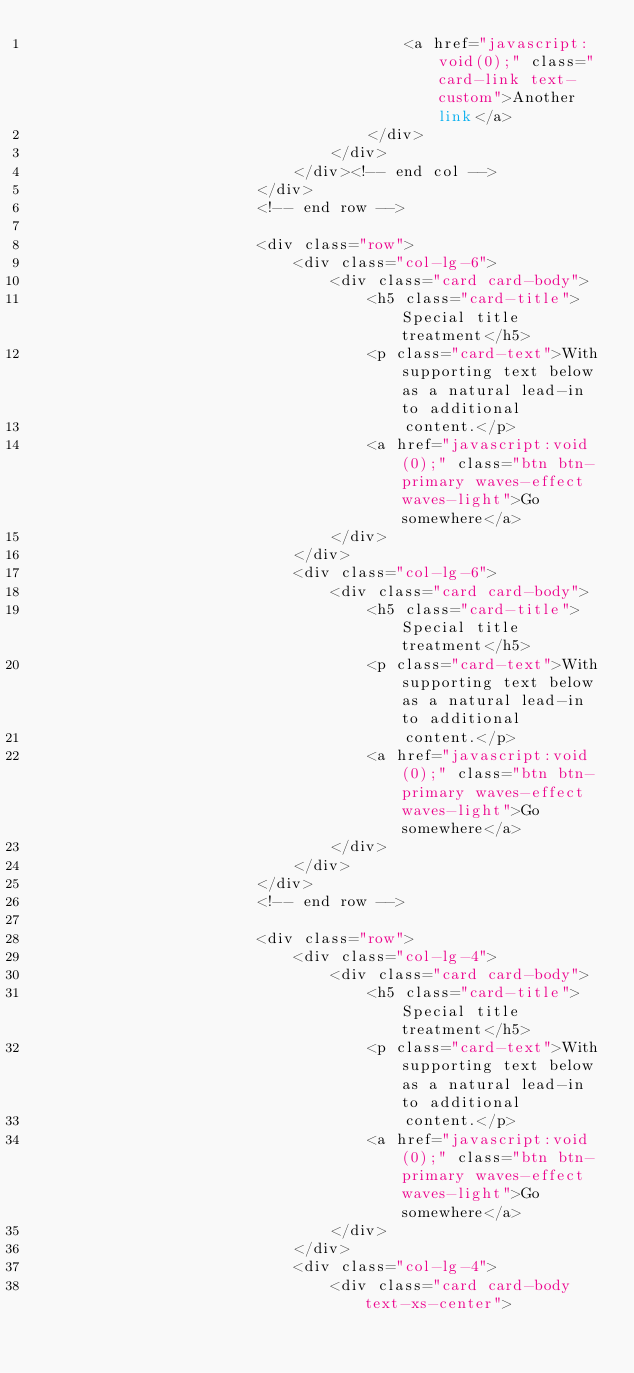<code> <loc_0><loc_0><loc_500><loc_500><_PHP_>                                        <a href="javascript:void(0);" class="card-link text-custom">Another link</a>
                                    </div>
                                </div>
                            </div><!-- end col -->
                        </div>
                        <!-- end row -->

                        <div class="row">
                            <div class="col-lg-6">
                                <div class="card card-body">
                                    <h5 class="card-title">Special title treatment</h5>
                                    <p class="card-text">With supporting text below as a natural lead-in to additional
                                        content.</p>
                                    <a href="javascript:void(0);" class="btn btn-primary waves-effect waves-light">Go somewhere</a>
                                </div>
                            </div>
                            <div class="col-lg-6">
                                <div class="card card-body">
                                    <h5 class="card-title">Special title treatment</h5>
                                    <p class="card-text">With supporting text below as a natural lead-in to additional
                                        content.</p>
                                    <a href="javascript:void(0);" class="btn btn-primary waves-effect waves-light">Go somewhere</a>
                                </div>
                            </div>
                        </div>
                        <!-- end row -->

                        <div class="row">
                            <div class="col-lg-4">
                                <div class="card card-body">
                                    <h5 class="card-title">Special title treatment</h5>
                                    <p class="card-text">With supporting text below as a natural lead-in to additional
                                        content.</p>
                                    <a href="javascript:void(0);" class="btn btn-primary waves-effect waves-light">Go somewhere</a>
                                </div>
                            </div>
                            <div class="col-lg-4">
                                <div class="card card-body text-xs-center"></code> 